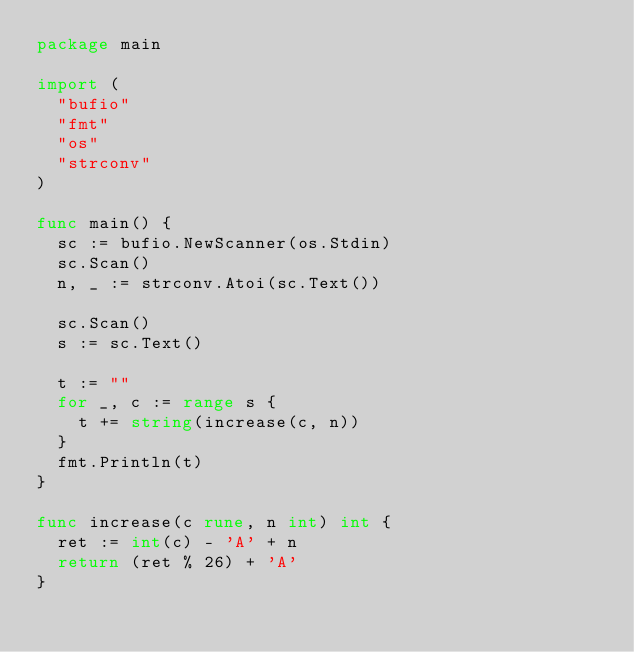Convert code to text. <code><loc_0><loc_0><loc_500><loc_500><_Go_>package main

import (
	"bufio"
	"fmt"
	"os"
	"strconv"
)

func main() {
	sc := bufio.NewScanner(os.Stdin)
	sc.Scan()
	n, _ := strconv.Atoi(sc.Text())

	sc.Scan()
	s := sc.Text()

	t := ""
	for _, c := range s {
		t += string(increase(c, n))
	}
	fmt.Println(t)
}

func increase(c rune, n int) int {
	ret := int(c) - 'A' + n
	return (ret % 26) + 'A'
}
</code> 